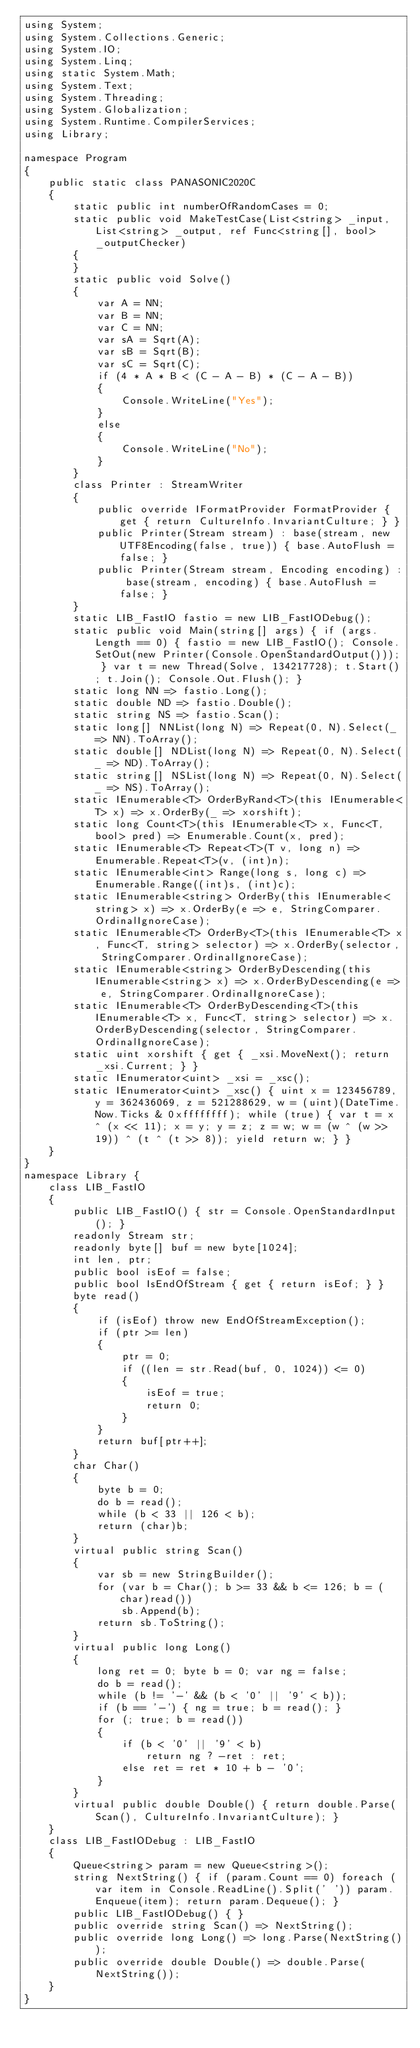Convert code to text. <code><loc_0><loc_0><loc_500><loc_500><_C#_>using System;
using System.Collections.Generic;
using System.IO;
using System.Linq;
using static System.Math;
using System.Text;
using System.Threading;
using System.Globalization;
using System.Runtime.CompilerServices;
using Library;

namespace Program
{
    public static class PANASONIC2020C
    {
        static public int numberOfRandomCases = 0;
        static public void MakeTestCase(List<string> _input, List<string> _output, ref Func<string[], bool> _outputChecker)
        {
        }
        static public void Solve()
        {
            var A = NN;
            var B = NN;
            var C = NN;
            var sA = Sqrt(A);
            var sB = Sqrt(B);
            var sC = Sqrt(C);
            if (4 * A * B < (C - A - B) * (C - A - B))
            {
                Console.WriteLine("Yes");
            }
            else
            {
                Console.WriteLine("No");
            }
        }
        class Printer : StreamWriter
        {
            public override IFormatProvider FormatProvider { get { return CultureInfo.InvariantCulture; } }
            public Printer(Stream stream) : base(stream, new UTF8Encoding(false, true)) { base.AutoFlush = false; }
            public Printer(Stream stream, Encoding encoding) : base(stream, encoding) { base.AutoFlush = false; }
        }
        static LIB_FastIO fastio = new LIB_FastIODebug();
        static public void Main(string[] args) { if (args.Length == 0) { fastio = new LIB_FastIO(); Console.SetOut(new Printer(Console.OpenStandardOutput())); } var t = new Thread(Solve, 134217728); t.Start(); t.Join(); Console.Out.Flush(); }
        static long NN => fastio.Long();
        static double ND => fastio.Double();
        static string NS => fastio.Scan();
        static long[] NNList(long N) => Repeat(0, N).Select(_ => NN).ToArray();
        static double[] NDList(long N) => Repeat(0, N).Select(_ => ND).ToArray();
        static string[] NSList(long N) => Repeat(0, N).Select(_ => NS).ToArray();
        static IEnumerable<T> OrderByRand<T>(this IEnumerable<T> x) => x.OrderBy(_ => xorshift);
        static long Count<T>(this IEnumerable<T> x, Func<T, bool> pred) => Enumerable.Count(x, pred);
        static IEnumerable<T> Repeat<T>(T v, long n) => Enumerable.Repeat<T>(v, (int)n);
        static IEnumerable<int> Range(long s, long c) => Enumerable.Range((int)s, (int)c);
        static IEnumerable<string> OrderBy(this IEnumerable<string> x) => x.OrderBy(e => e, StringComparer.OrdinalIgnoreCase);
        static IEnumerable<T> OrderBy<T>(this IEnumerable<T> x, Func<T, string> selector) => x.OrderBy(selector, StringComparer.OrdinalIgnoreCase);
        static IEnumerable<string> OrderByDescending(this IEnumerable<string> x) => x.OrderByDescending(e => e, StringComparer.OrdinalIgnoreCase);
        static IEnumerable<T> OrderByDescending<T>(this IEnumerable<T> x, Func<T, string> selector) => x.OrderByDescending(selector, StringComparer.OrdinalIgnoreCase);
        static uint xorshift { get { _xsi.MoveNext(); return _xsi.Current; } }
        static IEnumerator<uint> _xsi = _xsc();
        static IEnumerator<uint> _xsc() { uint x = 123456789, y = 362436069, z = 521288629, w = (uint)(DateTime.Now.Ticks & 0xffffffff); while (true) { var t = x ^ (x << 11); x = y; y = z; z = w; w = (w ^ (w >> 19)) ^ (t ^ (t >> 8)); yield return w; } }
    }
}
namespace Library {
    class LIB_FastIO
    {
        public LIB_FastIO() { str = Console.OpenStandardInput(); }
        readonly Stream str;
        readonly byte[] buf = new byte[1024];
        int len, ptr;
        public bool isEof = false;
        public bool IsEndOfStream { get { return isEof; } }
        byte read()
        {
            if (isEof) throw new EndOfStreamException();
            if (ptr >= len)
            {
                ptr = 0;
                if ((len = str.Read(buf, 0, 1024)) <= 0)
                {
                    isEof = true;
                    return 0;
                }
            }
            return buf[ptr++];
        }
        char Char()
        {
            byte b = 0;
            do b = read();
            while (b < 33 || 126 < b);
            return (char)b;
        }
        virtual public string Scan()
        {
            var sb = new StringBuilder();
            for (var b = Char(); b >= 33 && b <= 126; b = (char)read())
                sb.Append(b);
            return sb.ToString();
        }
        virtual public long Long()
        {
            long ret = 0; byte b = 0; var ng = false;
            do b = read();
            while (b != '-' && (b < '0' || '9' < b));
            if (b == '-') { ng = true; b = read(); }
            for (; true; b = read())
            {
                if (b < '0' || '9' < b)
                    return ng ? -ret : ret;
                else ret = ret * 10 + b - '0';
            }
        }
        virtual public double Double() { return double.Parse(Scan(), CultureInfo.InvariantCulture); }
    }
    class LIB_FastIODebug : LIB_FastIO
    {
        Queue<string> param = new Queue<string>();
        string NextString() { if (param.Count == 0) foreach (var item in Console.ReadLine().Split(' ')) param.Enqueue(item); return param.Dequeue(); }
        public LIB_FastIODebug() { }
        public override string Scan() => NextString();
        public override long Long() => long.Parse(NextString());
        public override double Double() => double.Parse(NextString());
    }
}
</code> 